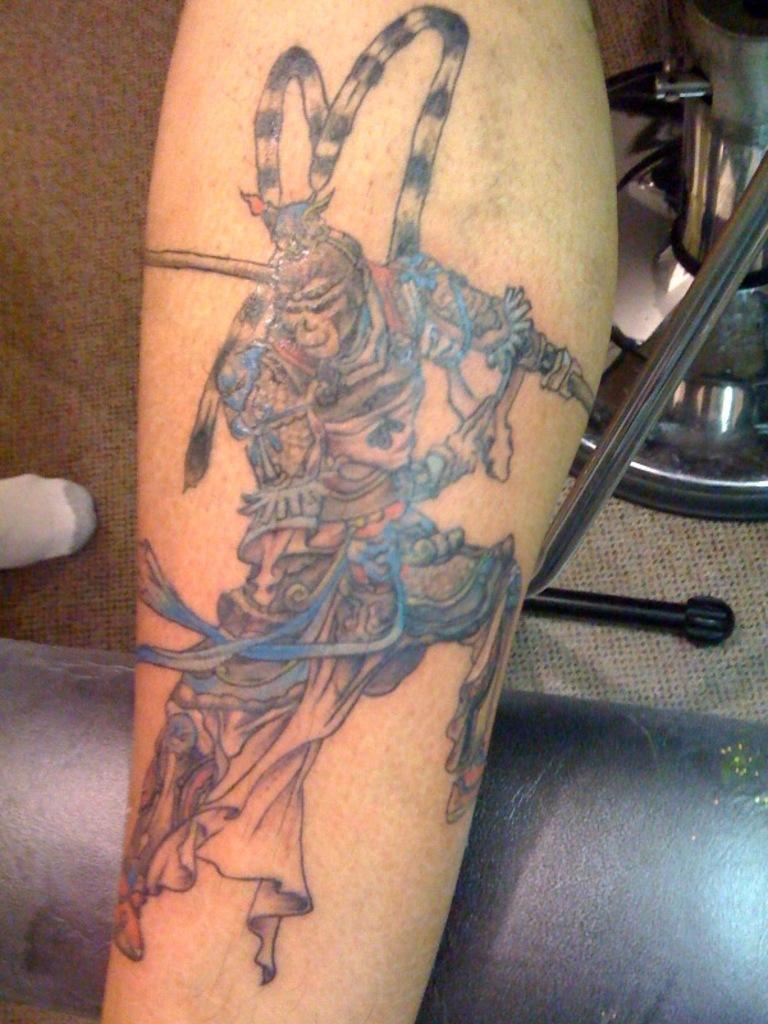Could you give a brief overview of what you see in this image? In this image I can see a tattoo on the leg of a person. Also there are some objects in the background. 